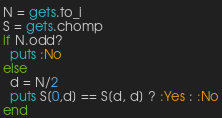Convert code to text. <code><loc_0><loc_0><loc_500><loc_500><_Ruby_>N = gets.to_i
S = gets.chomp
if N.odd?
  puts :No
else
  d = N/2
  puts S[0,d] == S[d, d] ? :Yes : :No
end</code> 